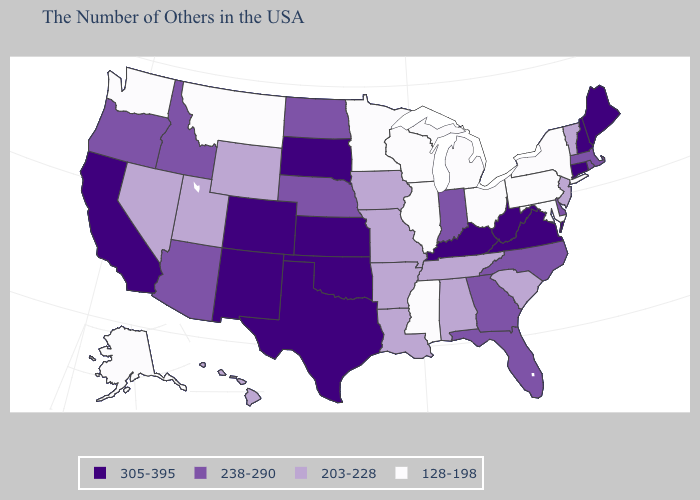Does Texas have a higher value than New York?
Give a very brief answer. Yes. Name the states that have a value in the range 238-290?
Answer briefly. Massachusetts, Rhode Island, Delaware, North Carolina, Florida, Georgia, Indiana, Nebraska, North Dakota, Arizona, Idaho, Oregon. Does South Dakota have the highest value in the MidWest?
Keep it brief. Yes. Does the first symbol in the legend represent the smallest category?
Short answer required. No. Name the states that have a value in the range 305-395?
Write a very short answer. Maine, New Hampshire, Connecticut, Virginia, West Virginia, Kentucky, Kansas, Oklahoma, Texas, South Dakota, Colorado, New Mexico, California. Does Mississippi have the lowest value in the USA?
Answer briefly. Yes. What is the lowest value in the MidWest?
Quick response, please. 128-198. What is the highest value in the USA?
Concise answer only. 305-395. Does West Virginia have a higher value than Texas?
Give a very brief answer. No. Name the states that have a value in the range 238-290?
Quick response, please. Massachusetts, Rhode Island, Delaware, North Carolina, Florida, Georgia, Indiana, Nebraska, North Dakota, Arizona, Idaho, Oregon. Which states have the lowest value in the USA?
Answer briefly. New York, Maryland, Pennsylvania, Ohio, Michigan, Wisconsin, Illinois, Mississippi, Minnesota, Montana, Washington, Alaska. What is the value of Minnesota?
Answer briefly. 128-198. Which states have the lowest value in the USA?
Short answer required. New York, Maryland, Pennsylvania, Ohio, Michigan, Wisconsin, Illinois, Mississippi, Minnesota, Montana, Washington, Alaska. What is the lowest value in states that border Maine?
Short answer required. 305-395. Which states have the highest value in the USA?
Concise answer only. Maine, New Hampshire, Connecticut, Virginia, West Virginia, Kentucky, Kansas, Oklahoma, Texas, South Dakota, Colorado, New Mexico, California. 